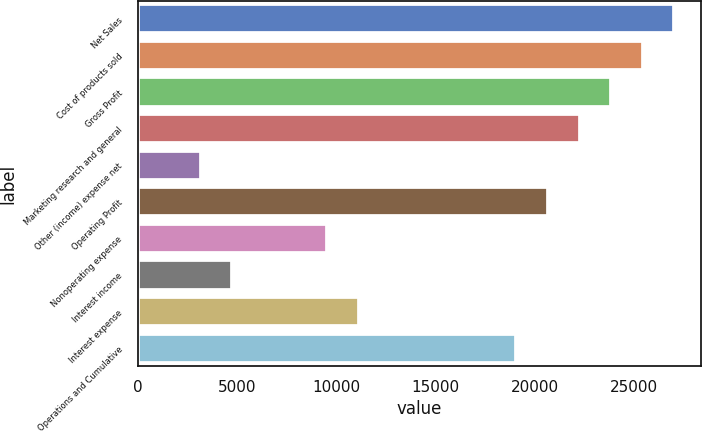Convert chart to OTSL. <chart><loc_0><loc_0><loc_500><loc_500><bar_chart><fcel>Net Sales<fcel>Cost of products sold<fcel>Gross Profit<fcel>Marketing research and general<fcel>Other (income) expense net<fcel>Operating Profit<fcel>Nonoperating expense<fcel>Interest income<fcel>Interest expense<fcel>Operations and Cumulative<nl><fcel>27032.1<fcel>25442.2<fcel>23852.2<fcel>22262.3<fcel>3183.16<fcel>20672.4<fcel>9542.88<fcel>4773.09<fcel>11132.8<fcel>19082.5<nl></chart> 